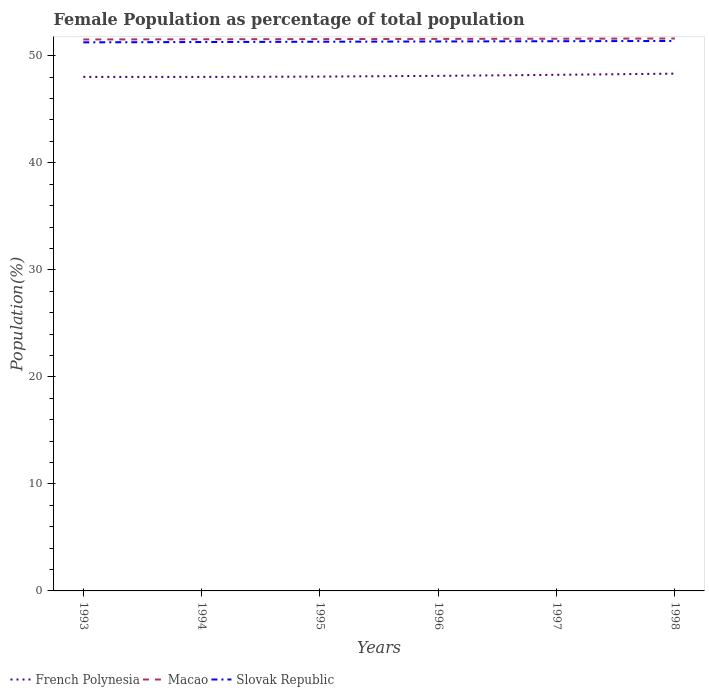How many different coloured lines are there?
Your answer should be compact. 3. Does the line corresponding to Slovak Republic intersect with the line corresponding to Macao?
Ensure brevity in your answer.  No. Is the number of lines equal to the number of legend labels?
Give a very brief answer. Yes. Across all years, what is the maximum female population in in French Polynesia?
Your answer should be compact. 48.02. What is the total female population in in Macao in the graph?
Provide a short and direct response. -0.02. What is the difference between the highest and the second highest female population in in French Polynesia?
Keep it short and to the point. 0.31. Is the female population in in French Polynesia strictly greater than the female population in in Macao over the years?
Offer a terse response. Yes. How many lines are there?
Keep it short and to the point. 3. How many years are there in the graph?
Give a very brief answer. 6. What is the difference between two consecutive major ticks on the Y-axis?
Keep it short and to the point. 10. Does the graph contain any zero values?
Your response must be concise. No. Does the graph contain grids?
Your answer should be compact. No. How many legend labels are there?
Your response must be concise. 3. How are the legend labels stacked?
Provide a short and direct response. Horizontal. What is the title of the graph?
Keep it short and to the point. Female Population as percentage of total population. What is the label or title of the Y-axis?
Provide a short and direct response. Population(%). What is the Population(%) of French Polynesia in 1993?
Keep it short and to the point. 48.03. What is the Population(%) of Macao in 1993?
Make the answer very short. 51.53. What is the Population(%) of Slovak Republic in 1993?
Provide a succinct answer. 51.26. What is the Population(%) of French Polynesia in 1994?
Provide a succinct answer. 48.02. What is the Population(%) in Macao in 1994?
Give a very brief answer. 51.54. What is the Population(%) in Slovak Republic in 1994?
Keep it short and to the point. 51.29. What is the Population(%) in French Polynesia in 1995?
Ensure brevity in your answer.  48.06. What is the Population(%) of Macao in 1995?
Your answer should be compact. 51.56. What is the Population(%) in Slovak Republic in 1995?
Provide a succinct answer. 51.31. What is the Population(%) of French Polynesia in 1996?
Your answer should be very brief. 48.13. What is the Population(%) of Macao in 1996?
Offer a very short reply. 51.58. What is the Population(%) in Slovak Republic in 1996?
Make the answer very short. 51.34. What is the Population(%) of French Polynesia in 1997?
Provide a short and direct response. 48.22. What is the Population(%) of Macao in 1997?
Offer a terse response. 51.59. What is the Population(%) in Slovak Republic in 1997?
Your answer should be compact. 51.36. What is the Population(%) in French Polynesia in 1998?
Keep it short and to the point. 48.33. What is the Population(%) of Macao in 1998?
Keep it short and to the point. 51.62. What is the Population(%) of Slovak Republic in 1998?
Keep it short and to the point. 51.38. Across all years, what is the maximum Population(%) of French Polynesia?
Your answer should be very brief. 48.33. Across all years, what is the maximum Population(%) in Macao?
Ensure brevity in your answer.  51.62. Across all years, what is the maximum Population(%) in Slovak Republic?
Keep it short and to the point. 51.38. Across all years, what is the minimum Population(%) of French Polynesia?
Your answer should be compact. 48.02. Across all years, what is the minimum Population(%) of Macao?
Your answer should be compact. 51.53. Across all years, what is the minimum Population(%) in Slovak Republic?
Give a very brief answer. 51.26. What is the total Population(%) in French Polynesia in the graph?
Ensure brevity in your answer.  288.78. What is the total Population(%) in Macao in the graph?
Provide a short and direct response. 309.42. What is the total Population(%) of Slovak Republic in the graph?
Offer a very short reply. 307.94. What is the difference between the Population(%) of French Polynesia in 1993 and that in 1994?
Your answer should be compact. 0. What is the difference between the Population(%) of Macao in 1993 and that in 1994?
Your answer should be very brief. -0.02. What is the difference between the Population(%) of Slovak Republic in 1993 and that in 1994?
Your response must be concise. -0.03. What is the difference between the Population(%) in French Polynesia in 1993 and that in 1995?
Your answer should be compact. -0.03. What is the difference between the Population(%) in Macao in 1993 and that in 1995?
Provide a succinct answer. -0.04. What is the difference between the Population(%) of Slovak Republic in 1993 and that in 1995?
Your answer should be compact. -0.06. What is the difference between the Population(%) in French Polynesia in 1993 and that in 1996?
Provide a succinct answer. -0.1. What is the difference between the Population(%) of Macao in 1993 and that in 1996?
Ensure brevity in your answer.  -0.05. What is the difference between the Population(%) of Slovak Republic in 1993 and that in 1996?
Your answer should be very brief. -0.08. What is the difference between the Population(%) in French Polynesia in 1993 and that in 1997?
Provide a succinct answer. -0.2. What is the difference between the Population(%) of Macao in 1993 and that in 1997?
Offer a very short reply. -0.07. What is the difference between the Population(%) of Slovak Republic in 1993 and that in 1997?
Your answer should be compact. -0.11. What is the difference between the Population(%) in French Polynesia in 1993 and that in 1998?
Give a very brief answer. -0.31. What is the difference between the Population(%) in Macao in 1993 and that in 1998?
Your response must be concise. -0.09. What is the difference between the Population(%) in Slovak Republic in 1993 and that in 1998?
Keep it short and to the point. -0.13. What is the difference between the Population(%) in French Polynesia in 1994 and that in 1995?
Your answer should be compact. -0.03. What is the difference between the Population(%) in Macao in 1994 and that in 1995?
Offer a very short reply. -0.02. What is the difference between the Population(%) in Slovak Republic in 1994 and that in 1995?
Your answer should be very brief. -0.03. What is the difference between the Population(%) in French Polynesia in 1994 and that in 1996?
Your response must be concise. -0.1. What is the difference between the Population(%) of Macao in 1994 and that in 1996?
Provide a short and direct response. -0.03. What is the difference between the Population(%) in Slovak Republic in 1994 and that in 1996?
Your answer should be compact. -0.05. What is the difference between the Population(%) in French Polynesia in 1994 and that in 1997?
Provide a succinct answer. -0.2. What is the difference between the Population(%) in Macao in 1994 and that in 1997?
Offer a terse response. -0.05. What is the difference between the Population(%) of Slovak Republic in 1994 and that in 1997?
Keep it short and to the point. -0.08. What is the difference between the Population(%) of French Polynesia in 1994 and that in 1998?
Keep it short and to the point. -0.31. What is the difference between the Population(%) in Macao in 1994 and that in 1998?
Offer a very short reply. -0.07. What is the difference between the Population(%) in Slovak Republic in 1994 and that in 1998?
Ensure brevity in your answer.  -0.1. What is the difference between the Population(%) of French Polynesia in 1995 and that in 1996?
Offer a terse response. -0.07. What is the difference between the Population(%) of Macao in 1995 and that in 1996?
Keep it short and to the point. -0.02. What is the difference between the Population(%) in Slovak Republic in 1995 and that in 1996?
Your answer should be compact. -0.03. What is the difference between the Population(%) of French Polynesia in 1995 and that in 1997?
Your answer should be compact. -0.17. What is the difference between the Population(%) of Macao in 1995 and that in 1997?
Offer a very short reply. -0.03. What is the difference between the Population(%) of Slovak Republic in 1995 and that in 1997?
Your answer should be compact. -0.05. What is the difference between the Population(%) of French Polynesia in 1995 and that in 1998?
Give a very brief answer. -0.28. What is the difference between the Population(%) of Macao in 1995 and that in 1998?
Your response must be concise. -0.05. What is the difference between the Population(%) of Slovak Republic in 1995 and that in 1998?
Your response must be concise. -0.07. What is the difference between the Population(%) of French Polynesia in 1996 and that in 1997?
Give a very brief answer. -0.1. What is the difference between the Population(%) in Macao in 1996 and that in 1997?
Your answer should be very brief. -0.02. What is the difference between the Population(%) of Slovak Republic in 1996 and that in 1997?
Ensure brevity in your answer.  -0.02. What is the difference between the Population(%) of French Polynesia in 1996 and that in 1998?
Give a very brief answer. -0.21. What is the difference between the Population(%) of Macao in 1996 and that in 1998?
Offer a very short reply. -0.04. What is the difference between the Population(%) in Slovak Republic in 1996 and that in 1998?
Make the answer very short. -0.05. What is the difference between the Population(%) of French Polynesia in 1997 and that in 1998?
Your response must be concise. -0.11. What is the difference between the Population(%) of Macao in 1997 and that in 1998?
Provide a short and direct response. -0.02. What is the difference between the Population(%) in Slovak Republic in 1997 and that in 1998?
Your response must be concise. -0.02. What is the difference between the Population(%) in French Polynesia in 1993 and the Population(%) in Macao in 1994?
Provide a succinct answer. -3.52. What is the difference between the Population(%) of French Polynesia in 1993 and the Population(%) of Slovak Republic in 1994?
Ensure brevity in your answer.  -3.26. What is the difference between the Population(%) of Macao in 1993 and the Population(%) of Slovak Republic in 1994?
Your answer should be compact. 0.24. What is the difference between the Population(%) of French Polynesia in 1993 and the Population(%) of Macao in 1995?
Your answer should be very brief. -3.54. What is the difference between the Population(%) of French Polynesia in 1993 and the Population(%) of Slovak Republic in 1995?
Make the answer very short. -3.29. What is the difference between the Population(%) in Macao in 1993 and the Population(%) in Slovak Republic in 1995?
Keep it short and to the point. 0.21. What is the difference between the Population(%) in French Polynesia in 1993 and the Population(%) in Macao in 1996?
Your answer should be very brief. -3.55. What is the difference between the Population(%) in French Polynesia in 1993 and the Population(%) in Slovak Republic in 1996?
Provide a succinct answer. -3.31. What is the difference between the Population(%) of Macao in 1993 and the Population(%) of Slovak Republic in 1996?
Give a very brief answer. 0.19. What is the difference between the Population(%) of French Polynesia in 1993 and the Population(%) of Macao in 1997?
Give a very brief answer. -3.57. What is the difference between the Population(%) in French Polynesia in 1993 and the Population(%) in Slovak Republic in 1997?
Provide a succinct answer. -3.34. What is the difference between the Population(%) of Macao in 1993 and the Population(%) of Slovak Republic in 1997?
Make the answer very short. 0.16. What is the difference between the Population(%) in French Polynesia in 1993 and the Population(%) in Macao in 1998?
Give a very brief answer. -3.59. What is the difference between the Population(%) in French Polynesia in 1993 and the Population(%) in Slovak Republic in 1998?
Make the answer very short. -3.36. What is the difference between the Population(%) in Macao in 1993 and the Population(%) in Slovak Republic in 1998?
Provide a succinct answer. 0.14. What is the difference between the Population(%) in French Polynesia in 1994 and the Population(%) in Macao in 1995?
Your answer should be compact. -3.54. What is the difference between the Population(%) in French Polynesia in 1994 and the Population(%) in Slovak Republic in 1995?
Offer a very short reply. -3.29. What is the difference between the Population(%) of Macao in 1994 and the Population(%) of Slovak Republic in 1995?
Ensure brevity in your answer.  0.23. What is the difference between the Population(%) of French Polynesia in 1994 and the Population(%) of Macao in 1996?
Make the answer very short. -3.56. What is the difference between the Population(%) in French Polynesia in 1994 and the Population(%) in Slovak Republic in 1996?
Ensure brevity in your answer.  -3.31. What is the difference between the Population(%) of Macao in 1994 and the Population(%) of Slovak Republic in 1996?
Keep it short and to the point. 0.21. What is the difference between the Population(%) in French Polynesia in 1994 and the Population(%) in Macao in 1997?
Your response must be concise. -3.57. What is the difference between the Population(%) in French Polynesia in 1994 and the Population(%) in Slovak Republic in 1997?
Offer a terse response. -3.34. What is the difference between the Population(%) in Macao in 1994 and the Population(%) in Slovak Republic in 1997?
Offer a terse response. 0.18. What is the difference between the Population(%) of French Polynesia in 1994 and the Population(%) of Macao in 1998?
Offer a very short reply. -3.59. What is the difference between the Population(%) of French Polynesia in 1994 and the Population(%) of Slovak Republic in 1998?
Provide a short and direct response. -3.36. What is the difference between the Population(%) in Macao in 1994 and the Population(%) in Slovak Republic in 1998?
Ensure brevity in your answer.  0.16. What is the difference between the Population(%) of French Polynesia in 1995 and the Population(%) of Macao in 1996?
Offer a very short reply. -3.52. What is the difference between the Population(%) in French Polynesia in 1995 and the Population(%) in Slovak Republic in 1996?
Offer a very short reply. -3.28. What is the difference between the Population(%) in Macao in 1995 and the Population(%) in Slovak Republic in 1996?
Offer a very short reply. 0.22. What is the difference between the Population(%) in French Polynesia in 1995 and the Population(%) in Macao in 1997?
Your response must be concise. -3.54. What is the difference between the Population(%) of French Polynesia in 1995 and the Population(%) of Slovak Republic in 1997?
Offer a terse response. -3.31. What is the difference between the Population(%) of Macao in 1995 and the Population(%) of Slovak Republic in 1997?
Ensure brevity in your answer.  0.2. What is the difference between the Population(%) of French Polynesia in 1995 and the Population(%) of Macao in 1998?
Ensure brevity in your answer.  -3.56. What is the difference between the Population(%) in French Polynesia in 1995 and the Population(%) in Slovak Republic in 1998?
Offer a very short reply. -3.33. What is the difference between the Population(%) in Macao in 1995 and the Population(%) in Slovak Republic in 1998?
Give a very brief answer. 0.18. What is the difference between the Population(%) of French Polynesia in 1996 and the Population(%) of Macao in 1997?
Provide a short and direct response. -3.47. What is the difference between the Population(%) in French Polynesia in 1996 and the Population(%) in Slovak Republic in 1997?
Offer a terse response. -3.24. What is the difference between the Population(%) of Macao in 1996 and the Population(%) of Slovak Republic in 1997?
Give a very brief answer. 0.22. What is the difference between the Population(%) of French Polynesia in 1996 and the Population(%) of Macao in 1998?
Ensure brevity in your answer.  -3.49. What is the difference between the Population(%) in French Polynesia in 1996 and the Population(%) in Slovak Republic in 1998?
Ensure brevity in your answer.  -3.26. What is the difference between the Population(%) of Macao in 1996 and the Population(%) of Slovak Republic in 1998?
Ensure brevity in your answer.  0.2. What is the difference between the Population(%) of French Polynesia in 1997 and the Population(%) of Macao in 1998?
Make the answer very short. -3.39. What is the difference between the Population(%) of French Polynesia in 1997 and the Population(%) of Slovak Republic in 1998?
Ensure brevity in your answer.  -3.16. What is the difference between the Population(%) in Macao in 1997 and the Population(%) in Slovak Republic in 1998?
Offer a terse response. 0.21. What is the average Population(%) of French Polynesia per year?
Offer a terse response. 48.13. What is the average Population(%) in Macao per year?
Provide a short and direct response. 51.57. What is the average Population(%) of Slovak Republic per year?
Your answer should be compact. 51.32. In the year 1993, what is the difference between the Population(%) of French Polynesia and Population(%) of Macao?
Give a very brief answer. -3.5. In the year 1993, what is the difference between the Population(%) in French Polynesia and Population(%) in Slovak Republic?
Provide a short and direct response. -3.23. In the year 1993, what is the difference between the Population(%) in Macao and Population(%) in Slovak Republic?
Make the answer very short. 0.27. In the year 1994, what is the difference between the Population(%) of French Polynesia and Population(%) of Macao?
Offer a terse response. -3.52. In the year 1994, what is the difference between the Population(%) in French Polynesia and Population(%) in Slovak Republic?
Ensure brevity in your answer.  -3.26. In the year 1994, what is the difference between the Population(%) in Macao and Population(%) in Slovak Republic?
Provide a short and direct response. 0.26. In the year 1995, what is the difference between the Population(%) in French Polynesia and Population(%) in Macao?
Your answer should be very brief. -3.51. In the year 1995, what is the difference between the Population(%) of French Polynesia and Population(%) of Slovak Republic?
Give a very brief answer. -3.26. In the year 1995, what is the difference between the Population(%) of Macao and Population(%) of Slovak Republic?
Offer a terse response. 0.25. In the year 1996, what is the difference between the Population(%) in French Polynesia and Population(%) in Macao?
Keep it short and to the point. -3.45. In the year 1996, what is the difference between the Population(%) of French Polynesia and Population(%) of Slovak Republic?
Keep it short and to the point. -3.21. In the year 1996, what is the difference between the Population(%) in Macao and Population(%) in Slovak Republic?
Make the answer very short. 0.24. In the year 1997, what is the difference between the Population(%) of French Polynesia and Population(%) of Macao?
Your answer should be compact. -3.37. In the year 1997, what is the difference between the Population(%) in French Polynesia and Population(%) in Slovak Republic?
Your answer should be compact. -3.14. In the year 1997, what is the difference between the Population(%) in Macao and Population(%) in Slovak Republic?
Offer a very short reply. 0.23. In the year 1998, what is the difference between the Population(%) of French Polynesia and Population(%) of Macao?
Your answer should be very brief. -3.28. In the year 1998, what is the difference between the Population(%) of French Polynesia and Population(%) of Slovak Republic?
Your response must be concise. -3.05. In the year 1998, what is the difference between the Population(%) of Macao and Population(%) of Slovak Republic?
Your answer should be compact. 0.23. What is the ratio of the Population(%) of French Polynesia in 1993 to that in 1994?
Offer a terse response. 1. What is the ratio of the Population(%) of Macao in 1993 to that in 1994?
Keep it short and to the point. 1. What is the ratio of the Population(%) of Slovak Republic in 1993 to that in 1994?
Keep it short and to the point. 1. What is the ratio of the Population(%) in Macao in 1993 to that in 1995?
Offer a terse response. 1. What is the ratio of the Population(%) of Slovak Republic in 1993 to that in 1995?
Ensure brevity in your answer.  1. What is the ratio of the Population(%) of Macao in 1993 to that in 1996?
Your response must be concise. 1. What is the ratio of the Population(%) of French Polynesia in 1993 to that in 1997?
Your answer should be compact. 1. What is the ratio of the Population(%) in Slovak Republic in 1993 to that in 1997?
Ensure brevity in your answer.  1. What is the ratio of the Population(%) of French Polynesia in 1993 to that in 1998?
Provide a short and direct response. 0.99. What is the ratio of the Population(%) of Macao in 1993 to that in 1998?
Give a very brief answer. 1. What is the ratio of the Population(%) of Slovak Republic in 1993 to that in 1998?
Your answer should be very brief. 1. What is the ratio of the Population(%) in French Polynesia in 1994 to that in 1995?
Make the answer very short. 1. What is the ratio of the Population(%) in French Polynesia in 1994 to that in 1996?
Offer a terse response. 1. What is the ratio of the Population(%) in Macao in 1994 to that in 1996?
Your answer should be very brief. 1. What is the ratio of the Population(%) of Slovak Republic in 1994 to that in 1997?
Provide a succinct answer. 1. What is the ratio of the Population(%) in French Polynesia in 1994 to that in 1998?
Make the answer very short. 0.99. What is the ratio of the Population(%) in Macao in 1994 to that in 1998?
Your response must be concise. 1. What is the ratio of the Population(%) of Slovak Republic in 1994 to that in 1998?
Offer a very short reply. 1. What is the ratio of the Population(%) of French Polynesia in 1995 to that in 1996?
Make the answer very short. 1. What is the ratio of the Population(%) in Macao in 1995 to that in 1996?
Your answer should be compact. 1. What is the ratio of the Population(%) of Slovak Republic in 1995 to that in 1996?
Give a very brief answer. 1. What is the ratio of the Population(%) of Macao in 1996 to that in 1997?
Make the answer very short. 1. What is the ratio of the Population(%) of French Polynesia in 1997 to that in 1998?
Your answer should be very brief. 1. What is the difference between the highest and the second highest Population(%) of French Polynesia?
Offer a terse response. 0.11. What is the difference between the highest and the second highest Population(%) in Macao?
Your response must be concise. 0.02. What is the difference between the highest and the second highest Population(%) in Slovak Republic?
Provide a short and direct response. 0.02. What is the difference between the highest and the lowest Population(%) of French Polynesia?
Keep it short and to the point. 0.31. What is the difference between the highest and the lowest Population(%) of Macao?
Keep it short and to the point. 0.09. What is the difference between the highest and the lowest Population(%) in Slovak Republic?
Keep it short and to the point. 0.13. 